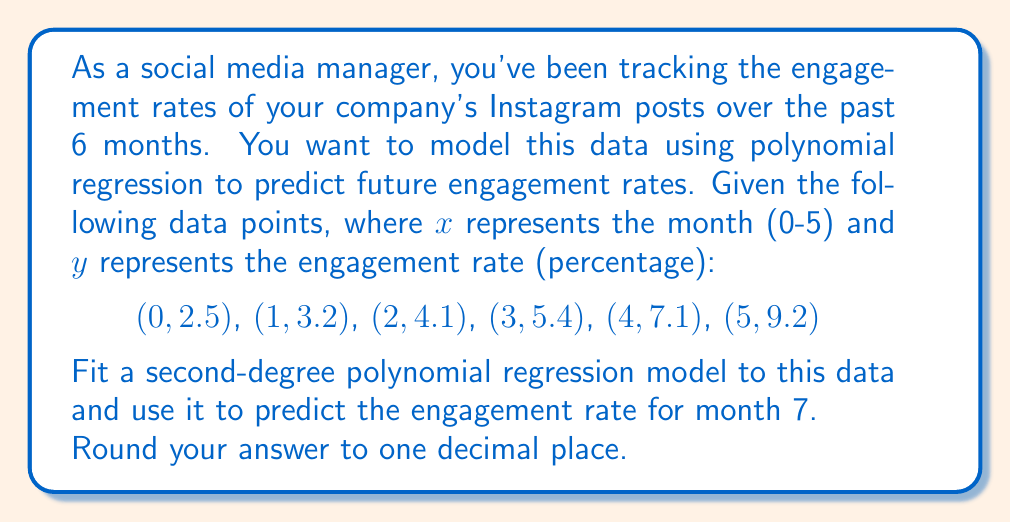Could you help me with this problem? To fit a second-degree polynomial regression model, we need to find the coefficients $a$, $b$, and $c$ in the equation:

$$y = ax^2 + bx + c$$

We can use the least squares method to find these coefficients. However, for simplicity, we'll use a polynomial regression calculator or spreadsheet software to obtain the coefficients.

Using such a tool, we get the following equation:

$$y = 0.1714x^2 + 0.4086x + 2.56$$

Now, to predict the engagement rate for month 7, we substitute $x = 7$ into our equation:

$$\begin{align*}
y &= 0.1714(7)^2 + 0.4086(7) + 2.56 \\
&= 0.1714(49) + 0.4086(7) + 2.56 \\
&= 8.3986 + 2.8602 + 2.56 \\
&= 13.8188
\end{align*}$$

Rounding to one decimal place, we get 13.8%.
Answer: 13.8% 